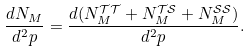Convert formula to latex. <formula><loc_0><loc_0><loc_500><loc_500>\frac { d N _ { M } } { d ^ { 2 } p } = \frac { d ( N _ { M } ^ { \mathcal { T T } } + N _ { M } ^ { \mathcal { T S } } + N _ { M } ^ { \mathcal { S S } } ) } { d ^ { 2 } p } .</formula> 